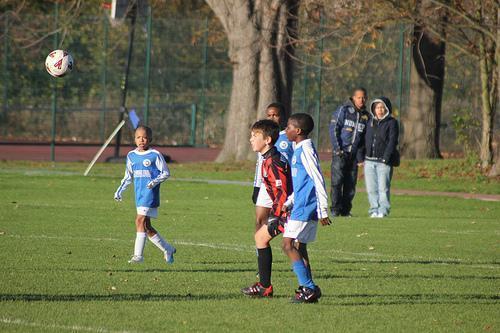How many balls are there?
Give a very brief answer. 1. 